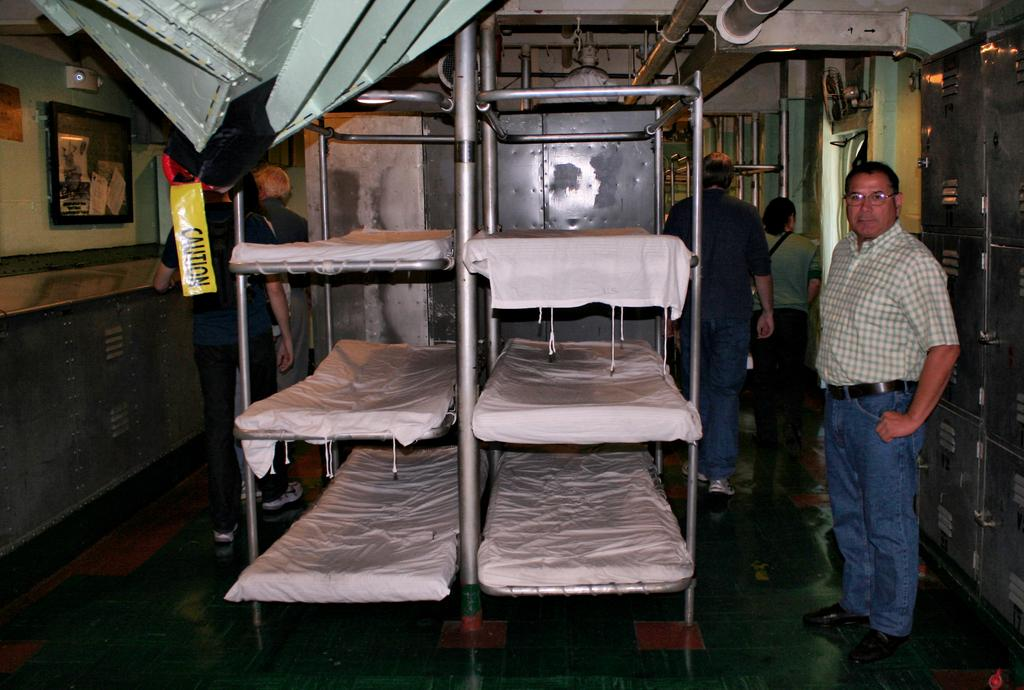<image>
Relay a brief, clear account of the picture shown. a man standing in front of two shelving racks of something, caution tape hanging nearby 